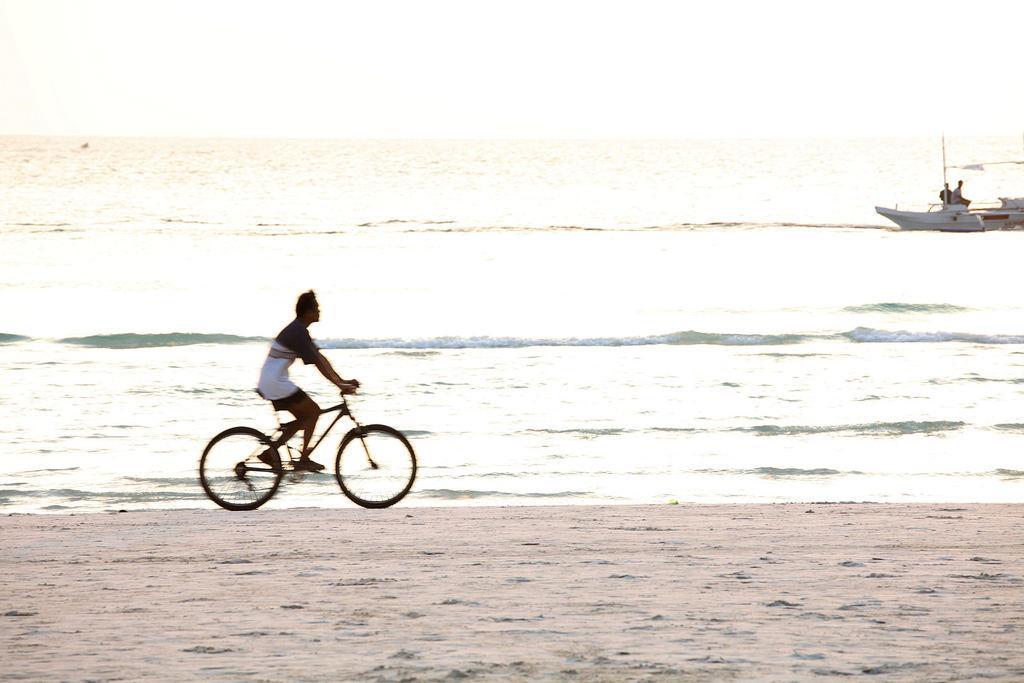In one or two sentences, can you explain what this image depicts? In this picture we can see a man who is riding a bicycle. This is water and there is a ship in the water. And this is sand. 